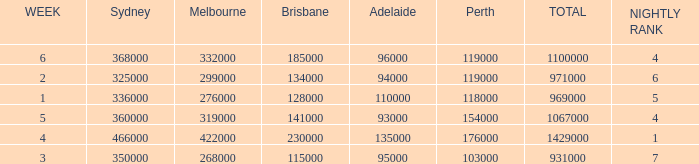What was the total rating on week 3?  931000.0. I'm looking to parse the entire table for insights. Could you assist me with that? {'header': ['WEEK', 'Sydney', 'Melbourne', 'Brisbane', 'Adelaide', 'Perth', 'TOTAL', 'NIGHTLY RANK'], 'rows': [['6', '368000', '332000', '185000', '96000', '119000', '1100000', '4'], ['2', '325000', '299000', '134000', '94000', '119000', '971000', '6'], ['1', '336000', '276000', '128000', '110000', '118000', '969000', '5'], ['5', '360000', '319000', '141000', '93000', '154000', '1067000', '4'], ['4', '466000', '422000', '230000', '135000', '176000', '1429000', '1'], ['3', '350000', '268000', '115000', '95000', '103000', '931000', '7']]} 